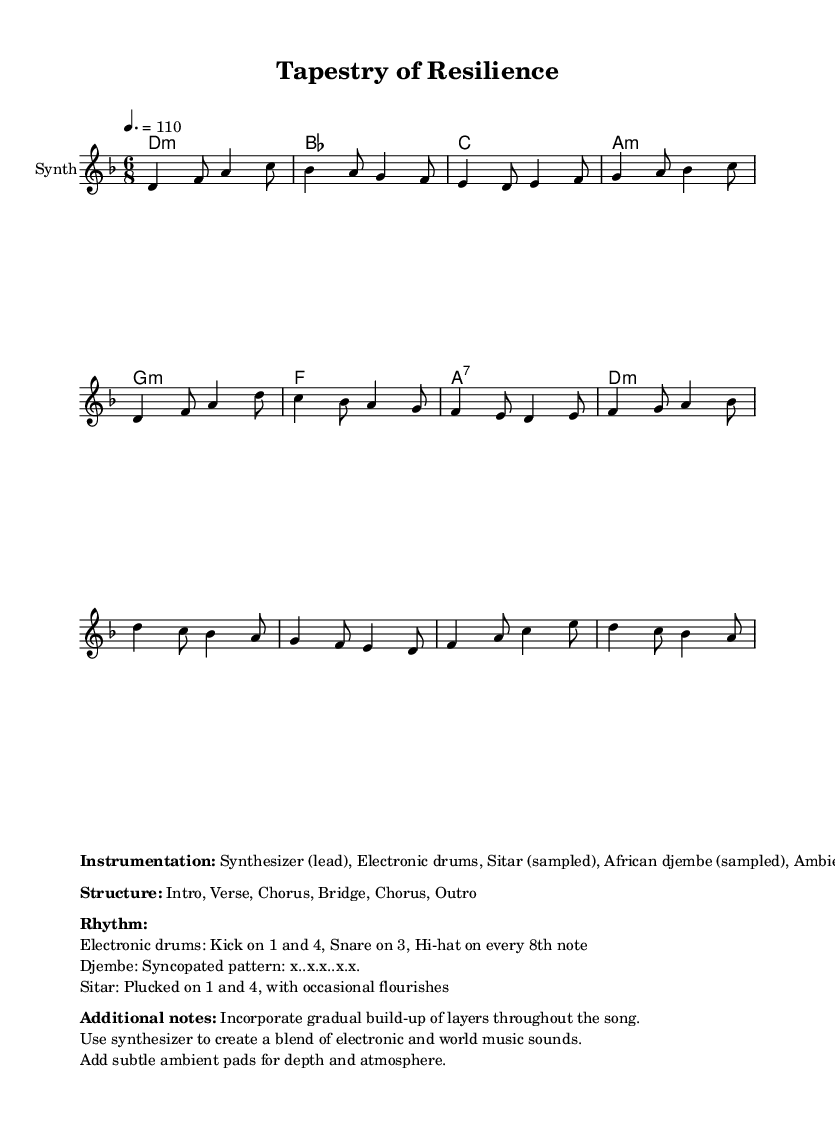What is the key signature of this music? The key signature is indicated in the global section of the code as D minor, which has one flat (B flat).
Answer: D minor What is the time signature of the piece? The time signature is specified in the global section as 6/8, indicating six eighth notes per measure.
Answer: 6/8 What is the tempo marking of the piece? The tempo marking in the global section indicates a speed of 110 beats per minute, which is denoted by the number following "tempo".
Answer: 110 What instruments are included in the instrumentation? The instrumentation is listed in the markup section, which specifies Synthesizer, Electronic drums, Sitar, African djembe, and Ambient pads.
Answer: Synthesizer, Electronic drums, Sitar, African djembe, Ambient pads How many sections are there in the structure of the piece? The structure of the piece is noted in the markup section as having an intro, verse, chorus, bridge, and outro, totaling five distinct sections, and one repetition of the chorus.
Answer: 6 What is the primary rhythm pattern for the electronic drums? The rhythm pattern for the electronic drums is detailed in the markup section, stating that the kick is on 1 and 4, while the snare is on 3 and hi-hat plays on every 8th note.
Answer: Kick on 1 and 4, Snare on 3, Hi-hat on every 8th note What is the significance of the gradual build-up of layers throughout the song? The note about the gradual build-up indicates a dynamic progression, enhancing emotional impact and creating depth in the musical texture as the piece develops.
Answer: Enhances emotional impact, creates depth 